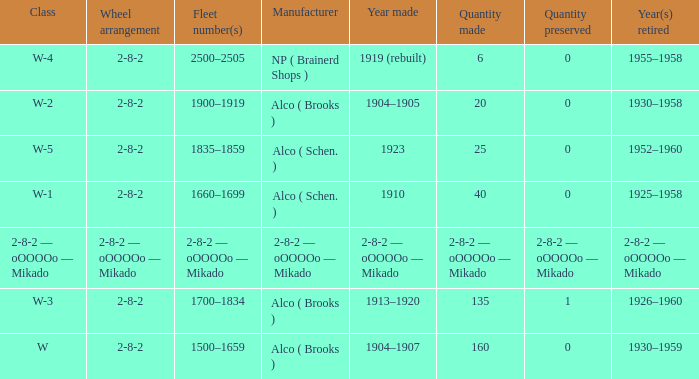Which class had a quantity made of 20? W-2. 